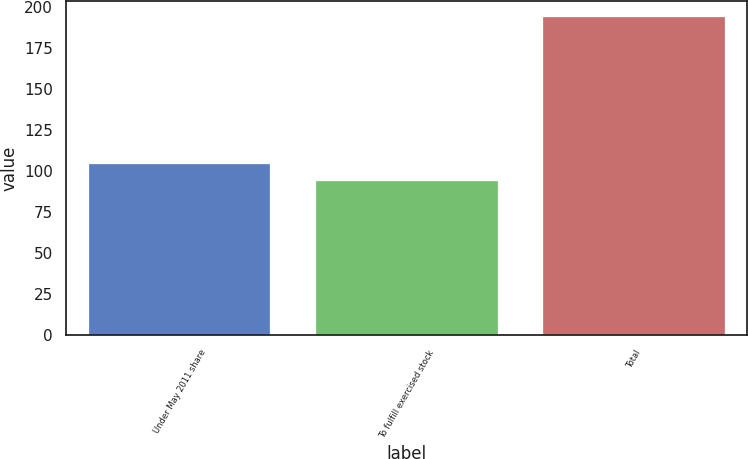Convert chart to OTSL. <chart><loc_0><loc_0><loc_500><loc_500><bar_chart><fcel>Under May 2011 share<fcel>To fulfill exercised stock<fcel>Total<nl><fcel>103.9<fcel>93.9<fcel>193.9<nl></chart> 